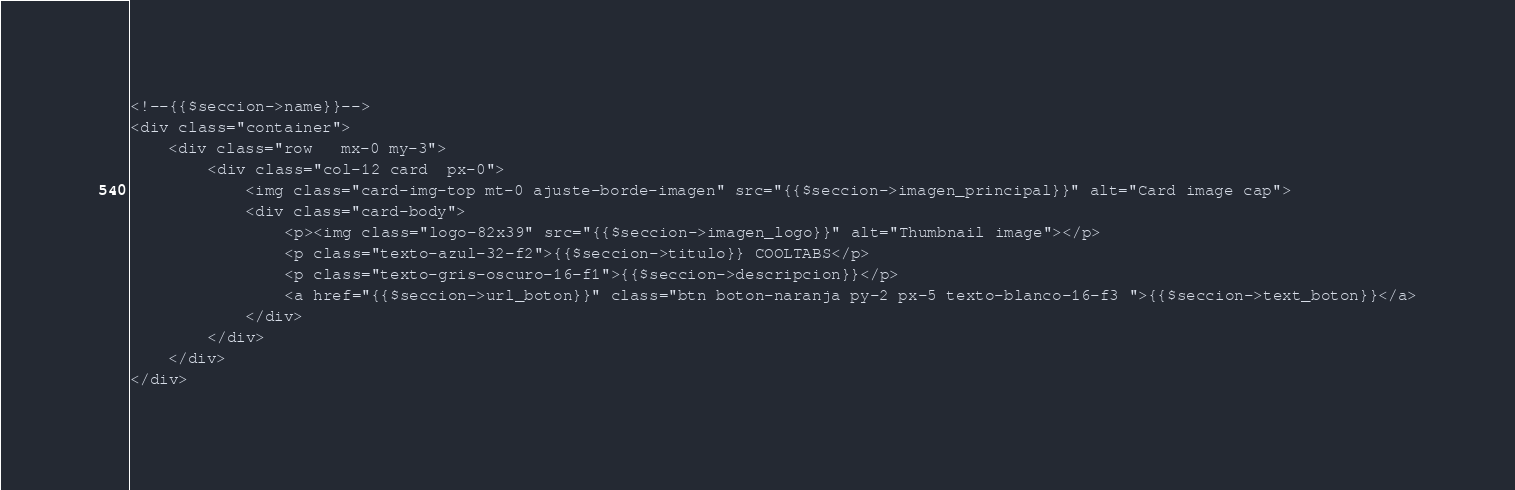Convert code to text. <code><loc_0><loc_0><loc_500><loc_500><_PHP_><!--{{$seccion->name}}-->
<div class="container">
    <div class="row   mx-0 my-3">
        <div class="col-12 card  px-0">
            <img class="card-img-top mt-0 ajuste-borde-imagen" src="{{$seccion->imagen_principal}}" alt="Card image cap">
            <div class="card-body">
                <p><img class="logo-82x39" src="{{$seccion->imagen_logo}}" alt="Thumbnail image"></p>
                <p class="texto-azul-32-f2">{{$seccion->titulo}} COOLTABS</p>
                <p class="texto-gris-oscuro-16-f1">{{$seccion->descripcion}}</p>
                <a href="{{$seccion->url_boton}}" class="btn boton-naranja py-2 px-5 texto-blanco-16-f3 ">{{$seccion->text_boton}}</a>
            </div>
        </div>
    </div>
</div></code> 